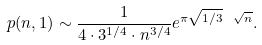<formula> <loc_0><loc_0><loc_500><loc_500>p ( n , 1 ) \sim \frac { 1 } { 4 \cdot 3 ^ { 1 / 4 } \cdot n ^ { 3 / 4 } } e ^ { \pi \sqrt { 1 / 3 } \ \sqrt { n } } .</formula> 